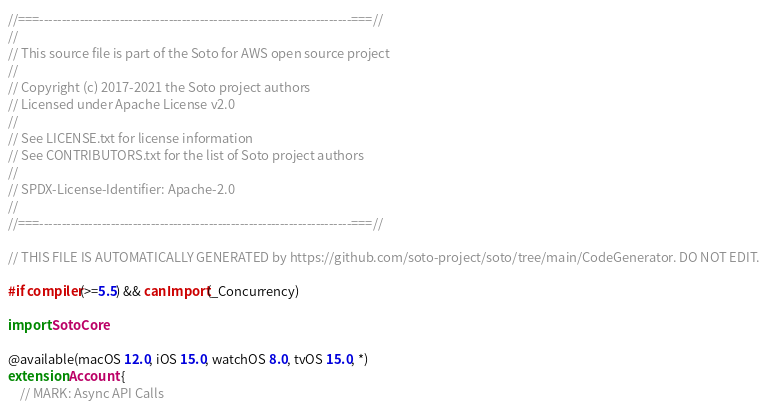<code> <loc_0><loc_0><loc_500><loc_500><_Swift_>//===----------------------------------------------------------------------===//
//
// This source file is part of the Soto for AWS open source project
//
// Copyright (c) 2017-2021 the Soto project authors
// Licensed under Apache License v2.0
//
// See LICENSE.txt for license information
// See CONTRIBUTORS.txt for the list of Soto project authors
//
// SPDX-License-Identifier: Apache-2.0
//
//===----------------------------------------------------------------------===//

// THIS FILE IS AUTOMATICALLY GENERATED by https://github.com/soto-project/soto/tree/main/CodeGenerator. DO NOT EDIT.

#if compiler(>=5.5) && canImport(_Concurrency)

import SotoCore

@available(macOS 12.0, iOS 15.0, watchOS 8.0, tvOS 15.0, *)
extension Account {
    // MARK: Async API Calls
</code> 